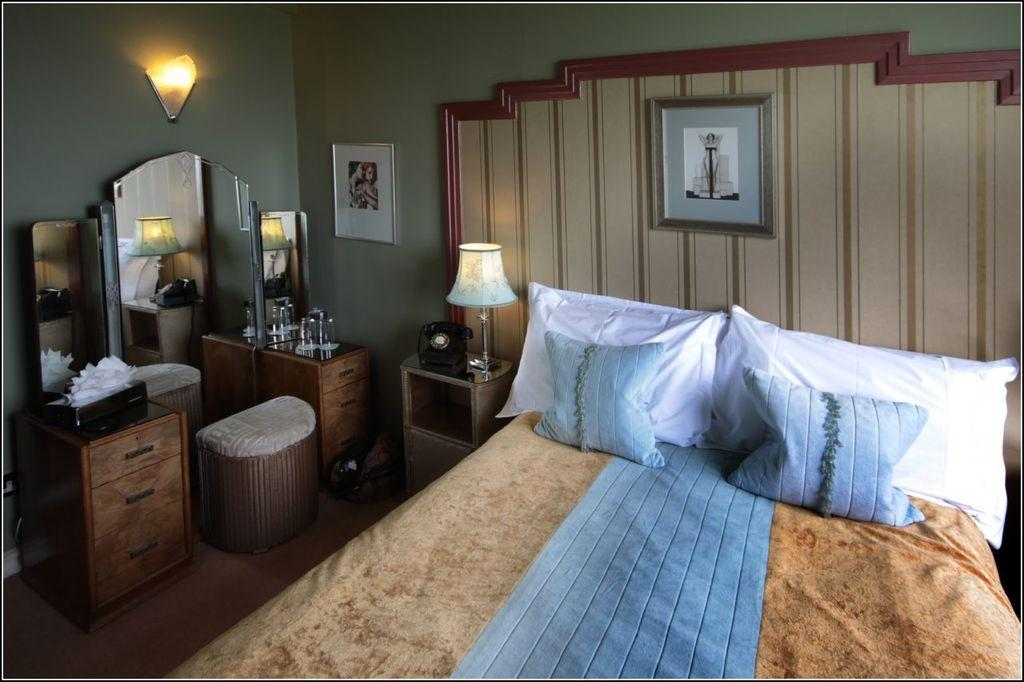What type of furniture is present in the image? There is a bed in the image. What can be seen on the bed? There are pillows on the bed. What type of lighting is present in the image? There is a lamp in the image. What type of communication device is present in the image? There is a telephone in the image. What type of reflective surface is present in the image? There is a mirror in the image. What type of decoration is present on the wall in the image? There are frames on the wall in the image. Can you see any signs of a fight between the ink and regret in the image? There is no mention of ink or regret in the image, and therefore no such conflict can be observed. 